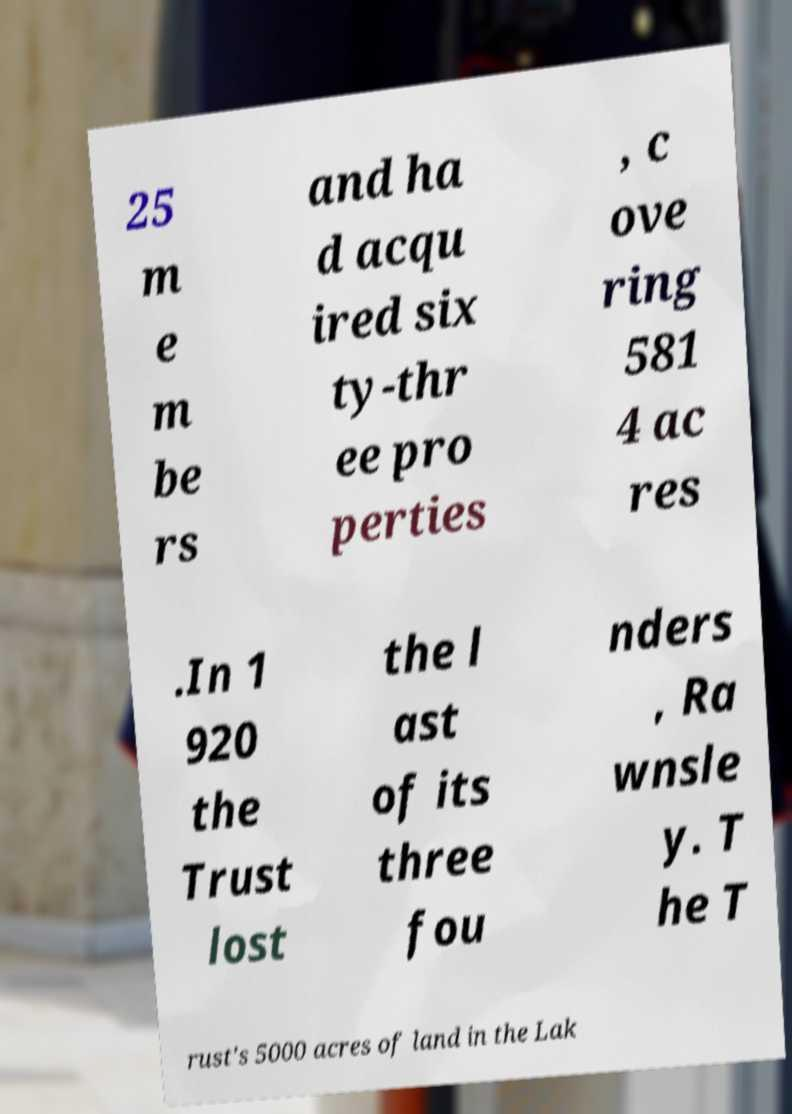Could you extract and type out the text from this image? 25 m e m be rs and ha d acqu ired six ty-thr ee pro perties , c ove ring 581 4 ac res .In 1 920 the Trust lost the l ast of its three fou nders , Ra wnsle y. T he T rust's 5000 acres of land in the Lak 